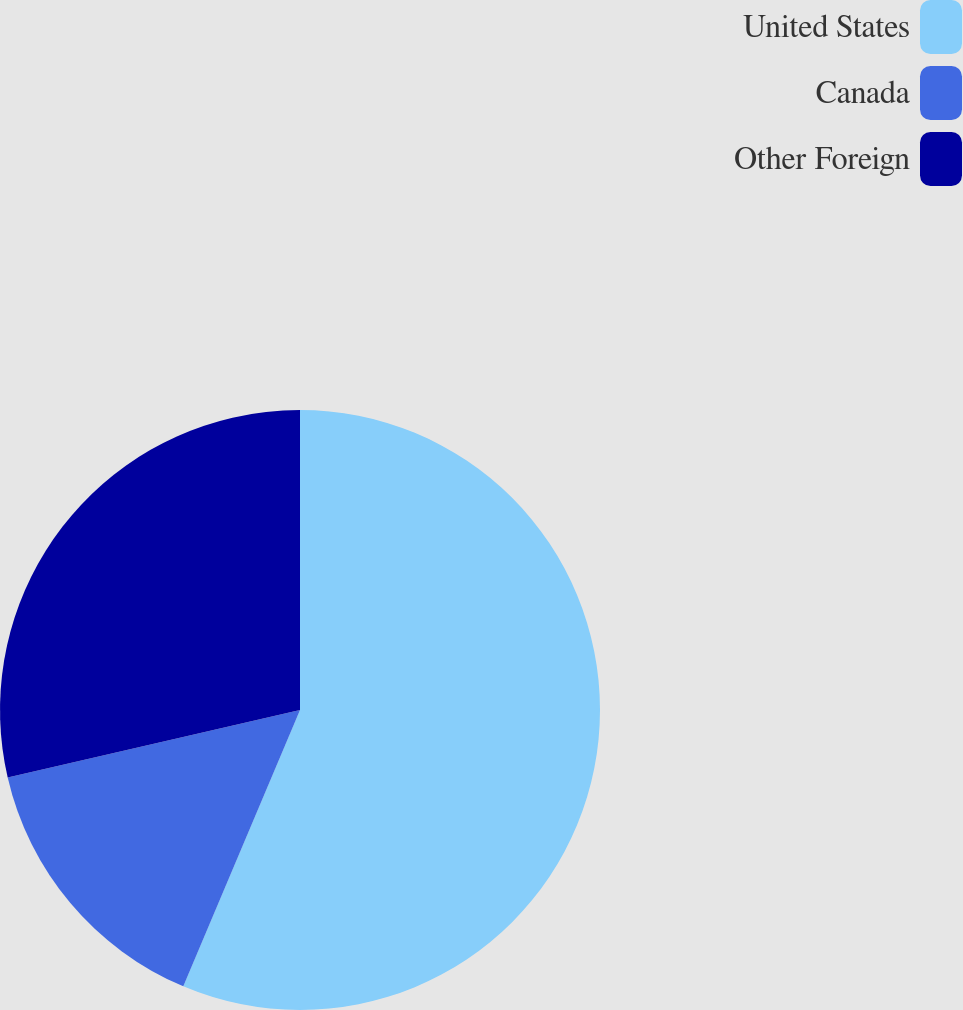Convert chart. <chart><loc_0><loc_0><loc_500><loc_500><pie_chart><fcel>United States<fcel>Canada<fcel>Other Foreign<nl><fcel>56.36%<fcel>15.03%<fcel>28.61%<nl></chart> 